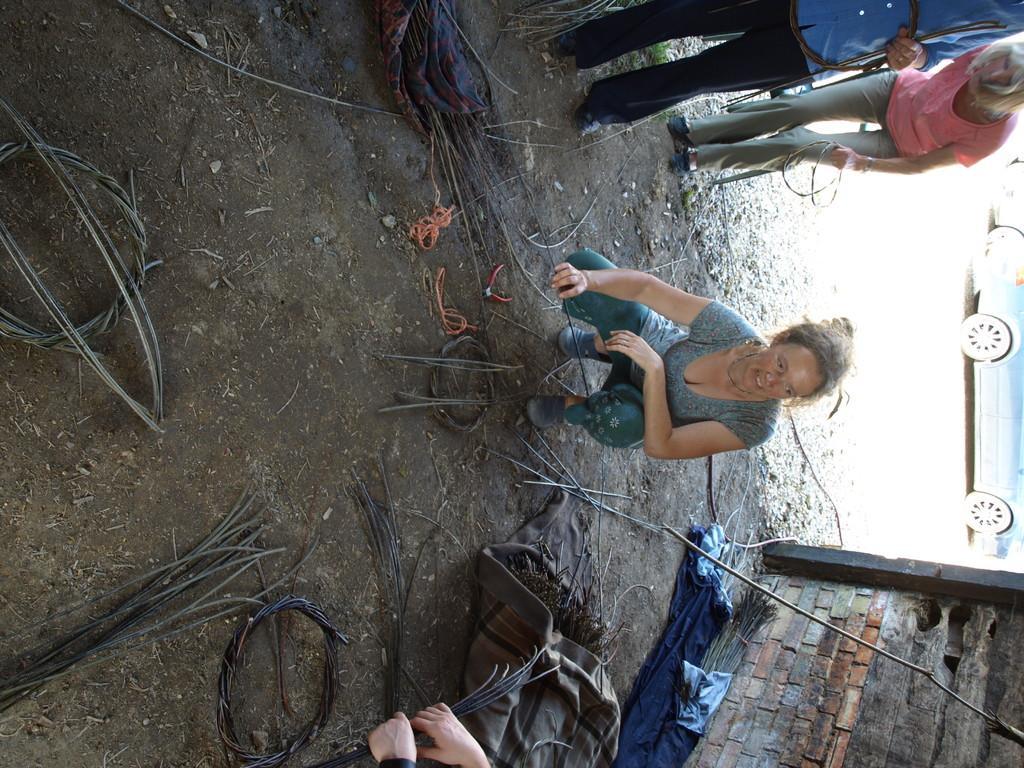Describe this image in one or two sentences. In this image I can see few people with different color dresses. I can see the clothes and wires on the ground. To the side of these people I can see the wall and there is a vehicle can be seen. 